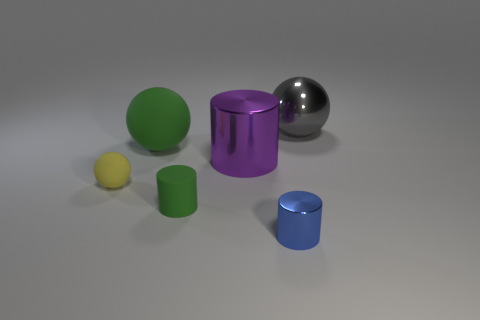Add 3 blue shiny objects. How many objects exist? 9 Subtract 0 cyan balls. How many objects are left? 6 Subtract all tiny green cylinders. Subtract all gray metallic balls. How many objects are left? 4 Add 4 metal balls. How many metal balls are left? 5 Add 4 purple cylinders. How many purple cylinders exist? 5 